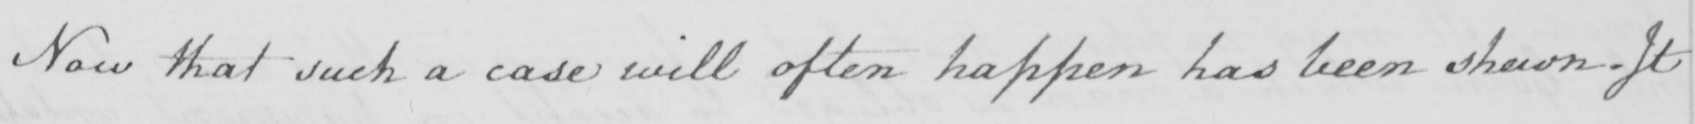Please provide the text content of this handwritten line. Now that such a case will often happen has been shewn . It 